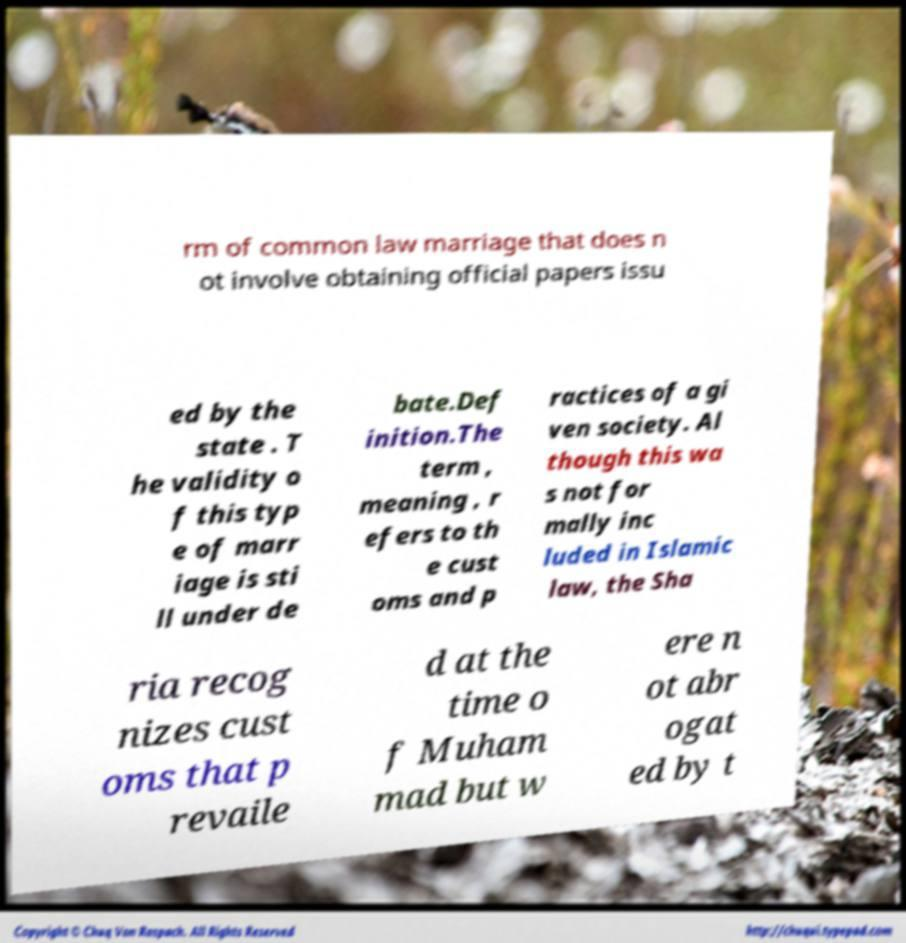I need the written content from this picture converted into text. Can you do that? rm of common law marriage that does n ot involve obtaining official papers issu ed by the state . T he validity o f this typ e of marr iage is sti ll under de bate.Def inition.The term , meaning , r efers to th e cust oms and p ractices of a gi ven society. Al though this wa s not for mally inc luded in Islamic law, the Sha ria recog nizes cust oms that p revaile d at the time o f Muham mad but w ere n ot abr ogat ed by t 